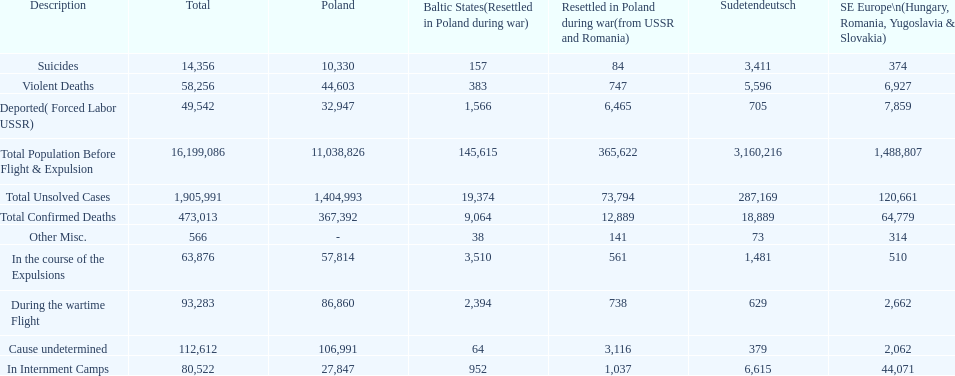What is the total of deaths in internment camps and during the wartime flight? 173,805. 